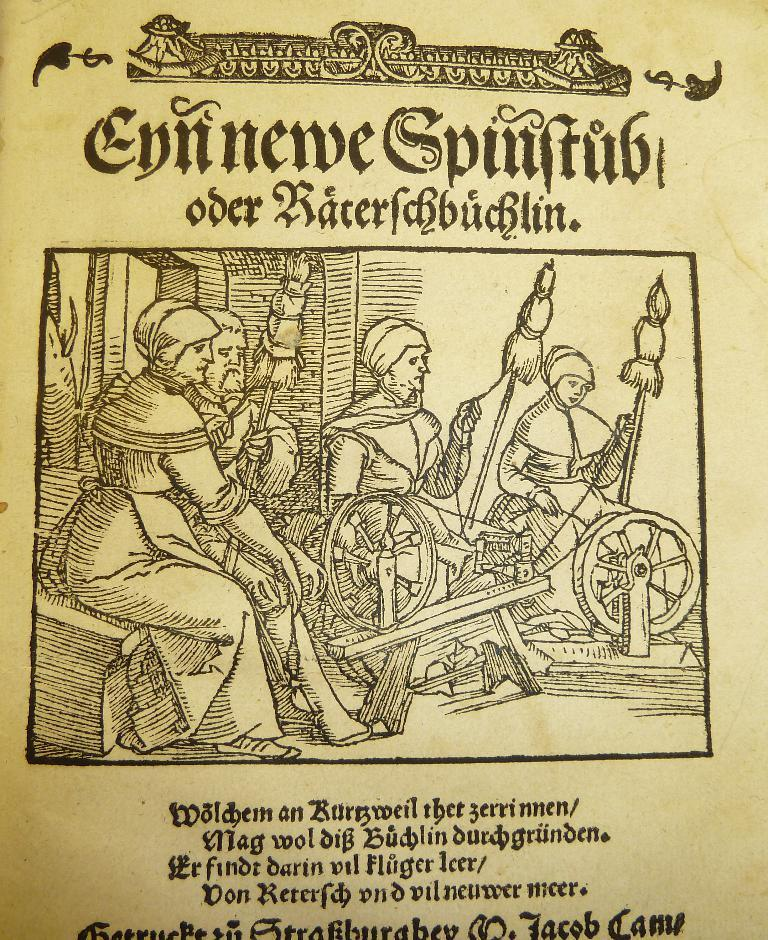What is featured in the image? There is a poster in the image. What can be seen on the poster? There are people depicted in the poster, along with wheels and sticks. Is there any text on the poster? Yes, there is text at the top of the poster. What type of soup is being served in the poster? There is no soup present in the poster; it features people, wheels, sticks, and text. Can you see a giraffe in the bedroom depicted in the poster? There is no bedroom depicted in the poster, nor is there a giraffe present. 